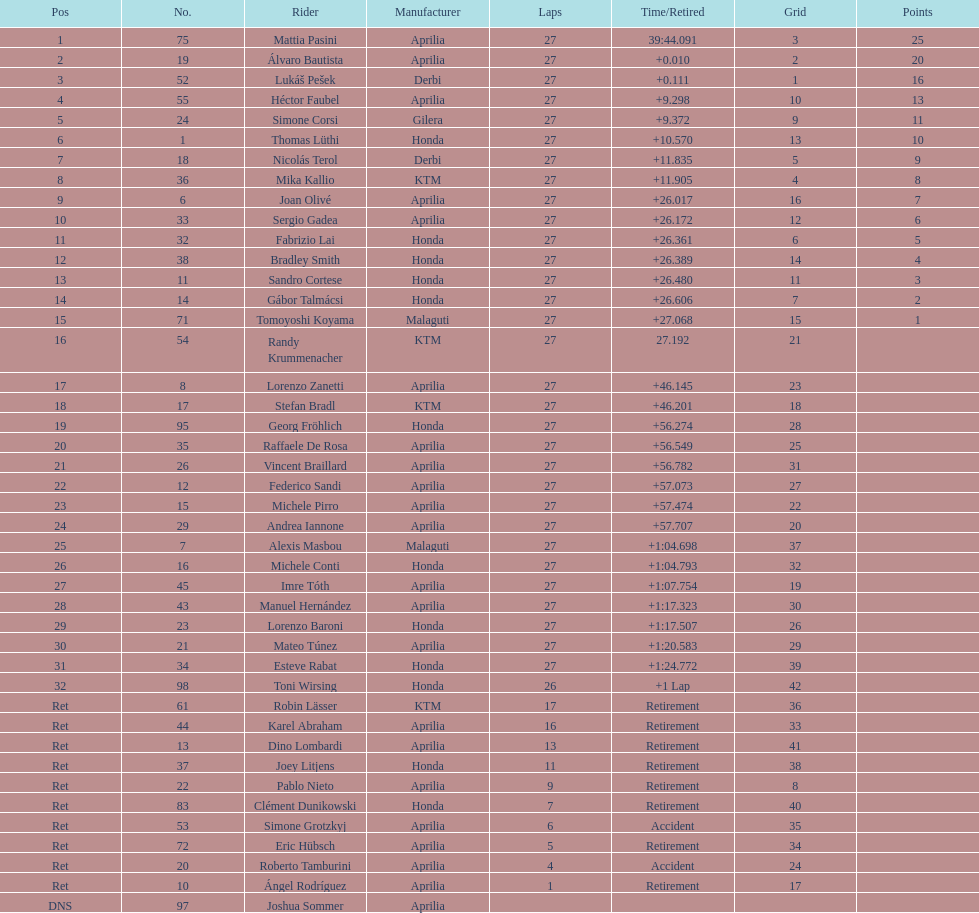Name a racer that had at least 20 points. Mattia Pasini. 